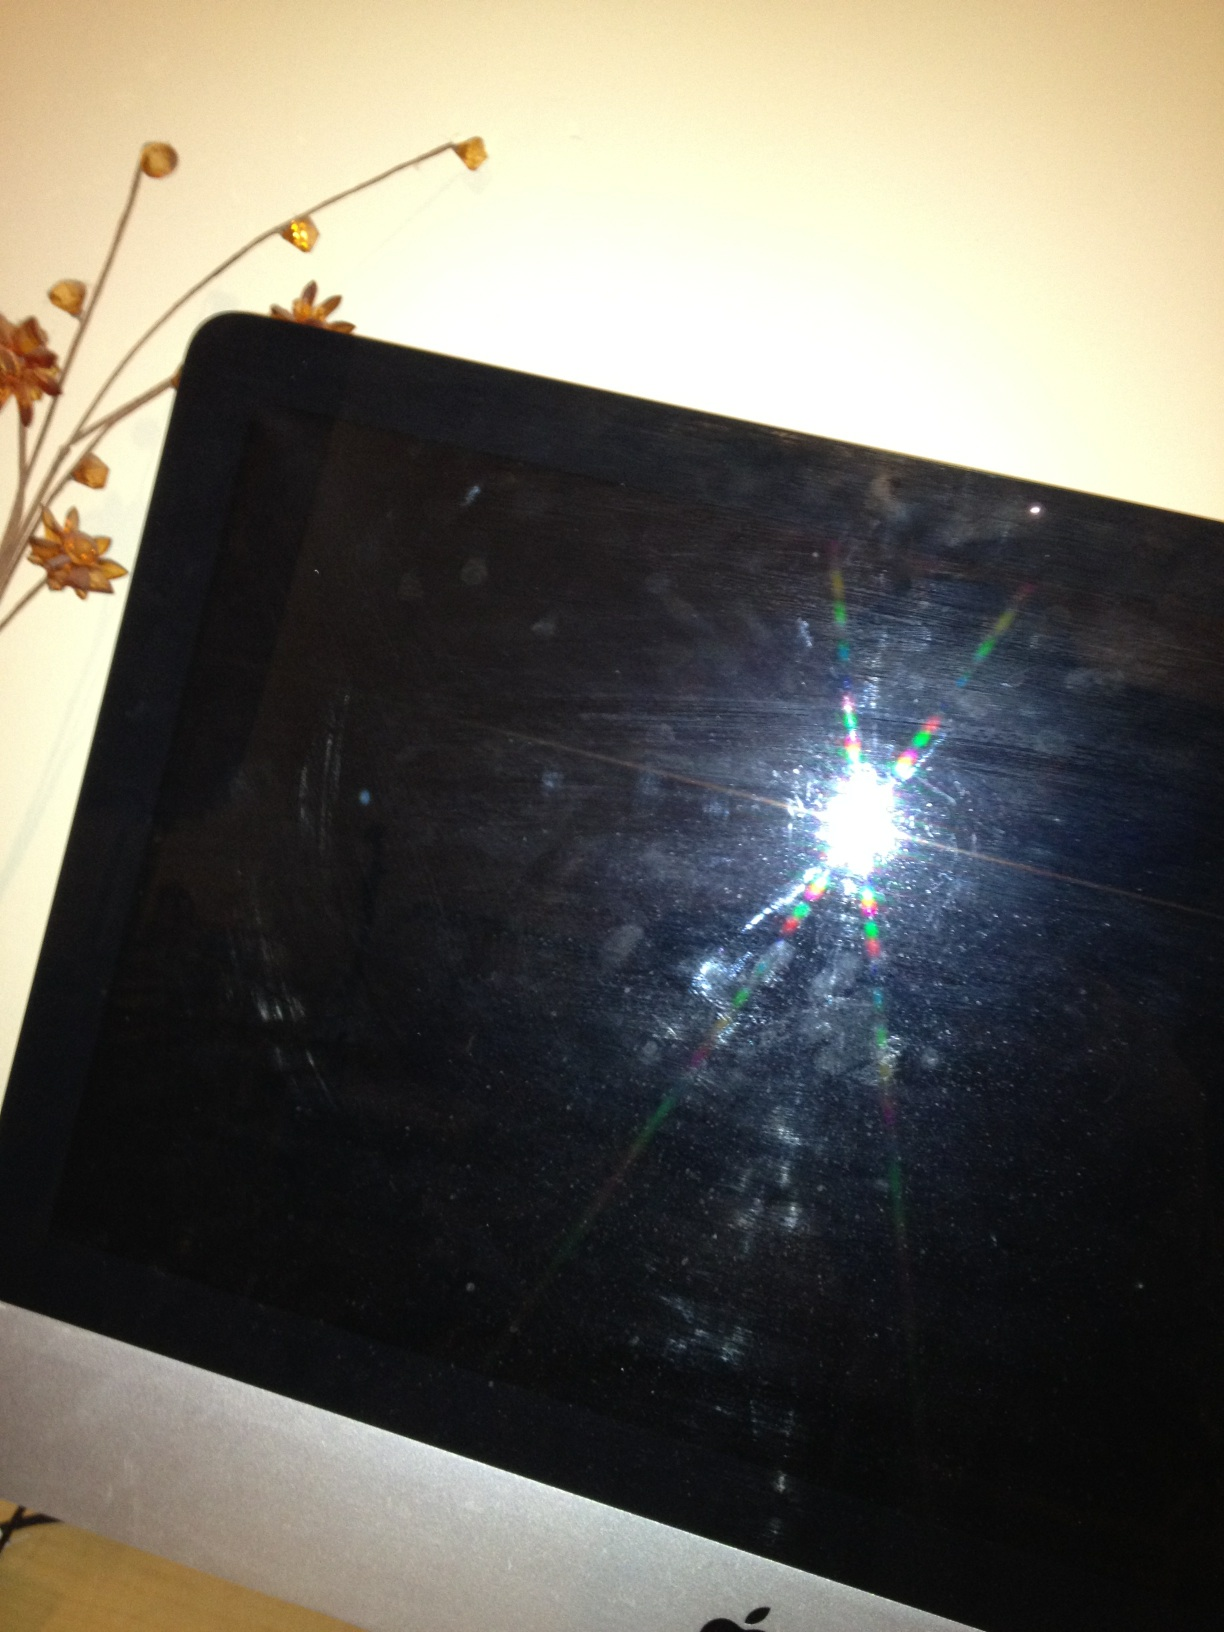What does this image depict? This image shows a dark screen, possibly that of a monitor or a TV. The screen reflects some light, and there are a few smudges, suggesting it's turned off or not displaying anything currently. How can I clean the smudges off the screen? To clean the smudges off your screen, use a microfiber cloth. Gently wipe the screen to remove dust and fingerprints. For stubborn smudges, slightly dampen the cloth with water or a screen cleaner that's safe for electronics, but make sure the cloth is not dripping wet. Avoid using harsh chemicals or paper towels as they can damage the screen. What kind of room might this device be in? This device, considering it’s an iMac, might be in a home office or a study. There is a decorative plant in the background, which suggests a space where someone works, studies, or spends a significant amount of time. It could also be in a living room where it serves multiple purposes such as entertainment and work. Do you think this room has a theme or specific style? The presence of the decorative branches with flowers suggests that the room might have a cozy and perhaps slightly rustic or natural theme. The simplicity of the visible decor implies a preference for minimalist or modern design elements. If this monitor could talk, what story do you think it would tell? If this monitor could talk, it might tell stories of late-night work sessions, streaming favorite TV shows, or even virtual meetings and calls. It could share the excitement of creative projects, the concentration of online learning, and the relaxation of watching movies. This screen has likely been a silent witness to many moments of productivity, entertainment, and even frustration, playing a crucial role in the daily life of its owner. 